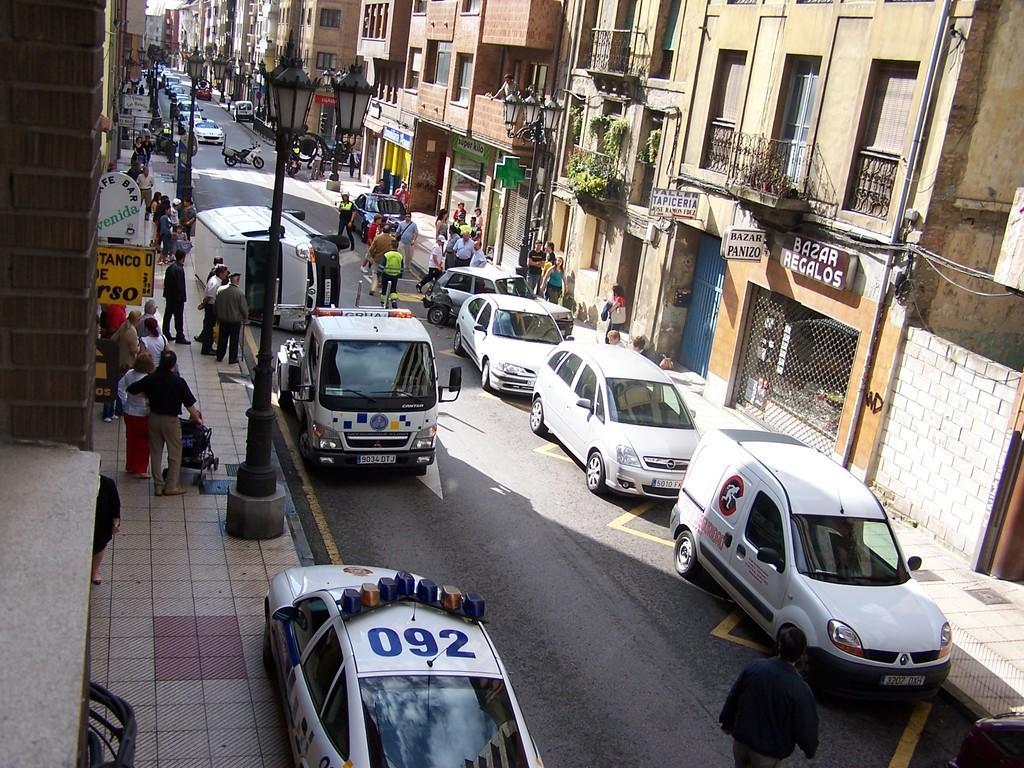In one or two sentences, can you explain what this image depicts? In this image we can see group of people standing on the ground , group of vehicles parked on the road , we can also see some light poles and a baby carrier on the ground. In the left and right side of the image we can see group of buildings with windows , plants , railings , a mesh and sign boards with some text. 